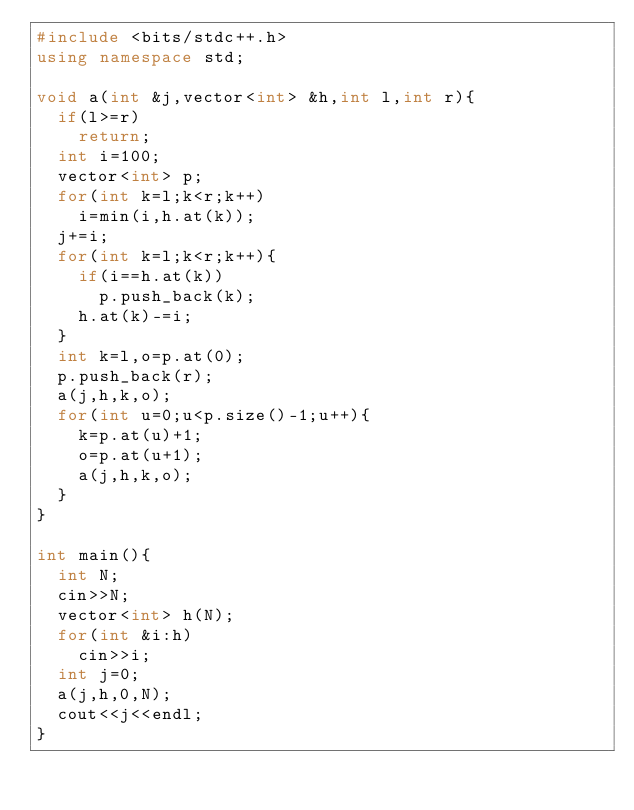<code> <loc_0><loc_0><loc_500><loc_500><_C++_>#include <bits/stdc++.h>
using namespace std;

void a(int &j,vector<int> &h,int l,int r){
  if(l>=r)
    return;
  int i=100;
  vector<int> p;
  for(int k=l;k<r;k++)
    i=min(i,h.at(k));
  j+=i;
  for(int k=l;k<r;k++){
    if(i==h.at(k))
      p.push_back(k);
    h.at(k)-=i;
  }
  int k=l,o=p.at(0);
  p.push_back(r);
  a(j,h,k,o);
  for(int u=0;u<p.size()-1;u++){
    k=p.at(u)+1;
    o=p.at(u+1);
    a(j,h,k,o);
  }
}

int main(){
  int N;
  cin>>N;
  vector<int> h(N);
  for(int &i:h)
    cin>>i;
  int j=0;
  a(j,h,0,N);
  cout<<j<<endl;
}</code> 